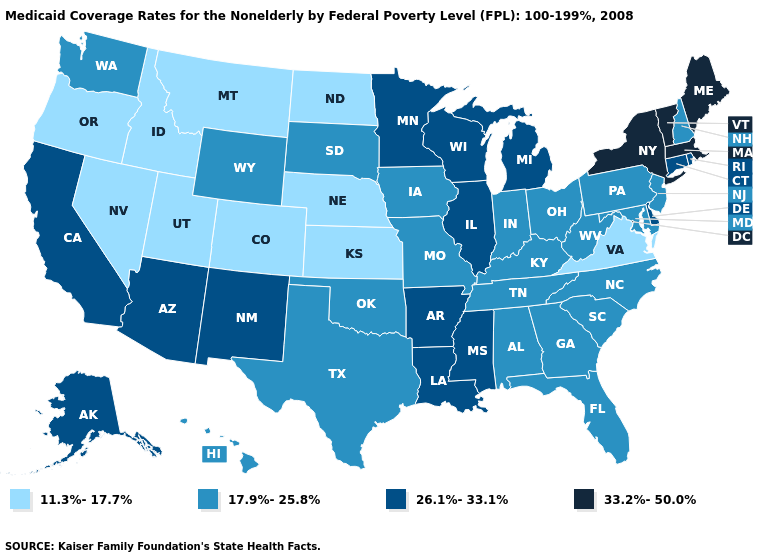Name the states that have a value in the range 17.9%-25.8%?
Short answer required. Alabama, Florida, Georgia, Hawaii, Indiana, Iowa, Kentucky, Maryland, Missouri, New Hampshire, New Jersey, North Carolina, Ohio, Oklahoma, Pennsylvania, South Carolina, South Dakota, Tennessee, Texas, Washington, West Virginia, Wyoming. Name the states that have a value in the range 33.2%-50.0%?
Short answer required. Maine, Massachusetts, New York, Vermont. Name the states that have a value in the range 26.1%-33.1%?
Give a very brief answer. Alaska, Arizona, Arkansas, California, Connecticut, Delaware, Illinois, Louisiana, Michigan, Minnesota, Mississippi, New Mexico, Rhode Island, Wisconsin. Name the states that have a value in the range 11.3%-17.7%?
Write a very short answer. Colorado, Idaho, Kansas, Montana, Nebraska, Nevada, North Dakota, Oregon, Utah, Virginia. What is the lowest value in the USA?
Give a very brief answer. 11.3%-17.7%. Name the states that have a value in the range 17.9%-25.8%?
Give a very brief answer. Alabama, Florida, Georgia, Hawaii, Indiana, Iowa, Kentucky, Maryland, Missouri, New Hampshire, New Jersey, North Carolina, Ohio, Oklahoma, Pennsylvania, South Carolina, South Dakota, Tennessee, Texas, Washington, West Virginia, Wyoming. What is the value of South Carolina?
Concise answer only. 17.9%-25.8%. What is the value of Connecticut?
Write a very short answer. 26.1%-33.1%. Name the states that have a value in the range 33.2%-50.0%?
Give a very brief answer. Maine, Massachusetts, New York, Vermont. Does Illinois have the highest value in the MidWest?
Keep it brief. Yes. Name the states that have a value in the range 17.9%-25.8%?
Answer briefly. Alabama, Florida, Georgia, Hawaii, Indiana, Iowa, Kentucky, Maryland, Missouri, New Hampshire, New Jersey, North Carolina, Ohio, Oklahoma, Pennsylvania, South Carolina, South Dakota, Tennessee, Texas, Washington, West Virginia, Wyoming. Does Colorado have the same value as Nebraska?
Answer briefly. Yes. What is the value of Alabama?
Be succinct. 17.9%-25.8%. Does North Carolina have a higher value than Idaho?
Answer briefly. Yes. 